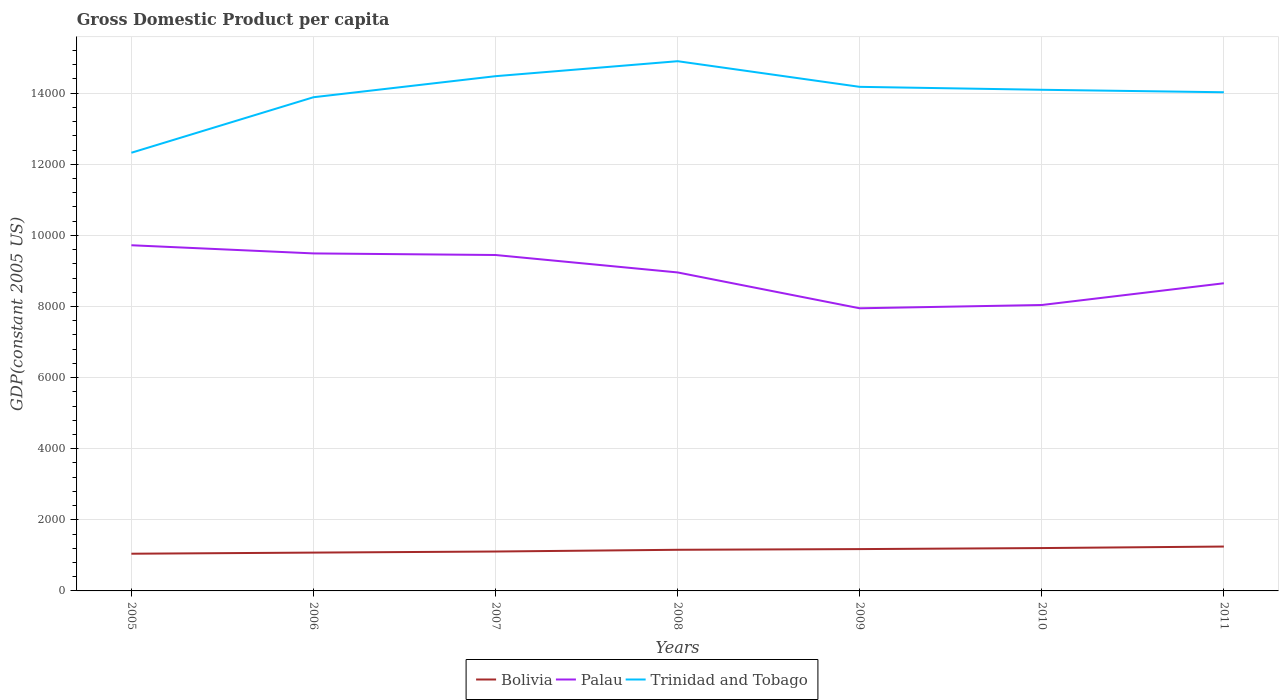How many different coloured lines are there?
Your response must be concise. 3. Does the line corresponding to Palau intersect with the line corresponding to Bolivia?
Your answer should be compact. No. Is the number of lines equal to the number of legend labels?
Your answer should be compact. Yes. Across all years, what is the maximum GDP per capita in Trinidad and Tobago?
Offer a very short reply. 1.23e+04. What is the total GDP per capita in Palau in the graph?
Offer a terse response. 490.37. What is the difference between the highest and the second highest GDP per capita in Bolivia?
Your response must be concise. 201.41. Are the values on the major ticks of Y-axis written in scientific E-notation?
Your response must be concise. No. Where does the legend appear in the graph?
Offer a very short reply. Bottom center. How are the legend labels stacked?
Provide a short and direct response. Horizontal. What is the title of the graph?
Give a very brief answer. Gross Domestic Product per capita. What is the label or title of the X-axis?
Ensure brevity in your answer.  Years. What is the label or title of the Y-axis?
Your response must be concise. GDP(constant 2005 US). What is the GDP(constant 2005 US) in Bolivia in 2005?
Ensure brevity in your answer.  1046.43. What is the GDP(constant 2005 US) in Palau in 2005?
Ensure brevity in your answer.  9721.5. What is the GDP(constant 2005 US) of Trinidad and Tobago in 2005?
Keep it short and to the point. 1.23e+04. What is the GDP(constant 2005 US) of Bolivia in 2006?
Offer a terse response. 1077.97. What is the GDP(constant 2005 US) in Palau in 2006?
Make the answer very short. 9491.85. What is the GDP(constant 2005 US) in Trinidad and Tobago in 2006?
Ensure brevity in your answer.  1.39e+04. What is the GDP(constant 2005 US) in Bolivia in 2007?
Provide a short and direct response. 1108.29. What is the GDP(constant 2005 US) of Palau in 2007?
Provide a succinct answer. 9447.16. What is the GDP(constant 2005 US) of Trinidad and Tobago in 2007?
Offer a very short reply. 1.45e+04. What is the GDP(constant 2005 US) in Bolivia in 2008?
Offer a very short reply. 1157.02. What is the GDP(constant 2005 US) of Palau in 2008?
Your answer should be compact. 8956.79. What is the GDP(constant 2005 US) of Trinidad and Tobago in 2008?
Ensure brevity in your answer.  1.49e+04. What is the GDP(constant 2005 US) in Bolivia in 2009?
Keep it short and to the point. 1176.39. What is the GDP(constant 2005 US) of Palau in 2009?
Your answer should be very brief. 7948.6. What is the GDP(constant 2005 US) of Trinidad and Tobago in 2009?
Keep it short and to the point. 1.42e+04. What is the GDP(constant 2005 US) of Bolivia in 2010?
Offer a very short reply. 1205.24. What is the GDP(constant 2005 US) of Palau in 2010?
Your response must be concise. 8041.01. What is the GDP(constant 2005 US) in Trinidad and Tobago in 2010?
Provide a succinct answer. 1.41e+04. What is the GDP(constant 2005 US) in Bolivia in 2011?
Offer a terse response. 1247.84. What is the GDP(constant 2005 US) in Palau in 2011?
Your answer should be very brief. 8652.35. What is the GDP(constant 2005 US) in Trinidad and Tobago in 2011?
Your response must be concise. 1.40e+04. Across all years, what is the maximum GDP(constant 2005 US) in Bolivia?
Provide a short and direct response. 1247.84. Across all years, what is the maximum GDP(constant 2005 US) of Palau?
Offer a terse response. 9721.5. Across all years, what is the maximum GDP(constant 2005 US) in Trinidad and Tobago?
Keep it short and to the point. 1.49e+04. Across all years, what is the minimum GDP(constant 2005 US) of Bolivia?
Ensure brevity in your answer.  1046.43. Across all years, what is the minimum GDP(constant 2005 US) of Palau?
Make the answer very short. 7948.6. Across all years, what is the minimum GDP(constant 2005 US) of Trinidad and Tobago?
Your answer should be very brief. 1.23e+04. What is the total GDP(constant 2005 US) of Bolivia in the graph?
Give a very brief answer. 8019.18. What is the total GDP(constant 2005 US) of Palau in the graph?
Ensure brevity in your answer.  6.23e+04. What is the total GDP(constant 2005 US) of Trinidad and Tobago in the graph?
Your answer should be compact. 9.79e+04. What is the difference between the GDP(constant 2005 US) in Bolivia in 2005 and that in 2006?
Make the answer very short. -31.54. What is the difference between the GDP(constant 2005 US) of Palau in 2005 and that in 2006?
Provide a short and direct response. 229.65. What is the difference between the GDP(constant 2005 US) in Trinidad and Tobago in 2005 and that in 2006?
Keep it short and to the point. -1561.05. What is the difference between the GDP(constant 2005 US) of Bolivia in 2005 and that in 2007?
Your answer should be very brief. -61.86. What is the difference between the GDP(constant 2005 US) in Palau in 2005 and that in 2007?
Your answer should be very brief. 274.34. What is the difference between the GDP(constant 2005 US) of Trinidad and Tobago in 2005 and that in 2007?
Keep it short and to the point. -2153.18. What is the difference between the GDP(constant 2005 US) of Bolivia in 2005 and that in 2008?
Keep it short and to the point. -110.59. What is the difference between the GDP(constant 2005 US) of Palau in 2005 and that in 2008?
Your answer should be very brief. 764.71. What is the difference between the GDP(constant 2005 US) of Trinidad and Tobago in 2005 and that in 2008?
Make the answer very short. -2574.42. What is the difference between the GDP(constant 2005 US) of Bolivia in 2005 and that in 2009?
Give a very brief answer. -129.96. What is the difference between the GDP(constant 2005 US) of Palau in 2005 and that in 2009?
Your answer should be very brief. 1772.9. What is the difference between the GDP(constant 2005 US) in Trinidad and Tobago in 2005 and that in 2009?
Keep it short and to the point. -1853.08. What is the difference between the GDP(constant 2005 US) in Bolivia in 2005 and that in 2010?
Provide a succinct answer. -158.82. What is the difference between the GDP(constant 2005 US) of Palau in 2005 and that in 2010?
Make the answer very short. 1680.49. What is the difference between the GDP(constant 2005 US) of Trinidad and Tobago in 2005 and that in 2010?
Ensure brevity in your answer.  -1770.83. What is the difference between the GDP(constant 2005 US) of Bolivia in 2005 and that in 2011?
Provide a succinct answer. -201.41. What is the difference between the GDP(constant 2005 US) of Palau in 2005 and that in 2011?
Provide a succinct answer. 1069.15. What is the difference between the GDP(constant 2005 US) of Trinidad and Tobago in 2005 and that in 2011?
Your answer should be compact. -1701.08. What is the difference between the GDP(constant 2005 US) in Bolivia in 2006 and that in 2007?
Provide a short and direct response. -30.32. What is the difference between the GDP(constant 2005 US) in Palau in 2006 and that in 2007?
Keep it short and to the point. 44.69. What is the difference between the GDP(constant 2005 US) of Trinidad and Tobago in 2006 and that in 2007?
Keep it short and to the point. -592.13. What is the difference between the GDP(constant 2005 US) in Bolivia in 2006 and that in 2008?
Provide a short and direct response. -79.05. What is the difference between the GDP(constant 2005 US) in Palau in 2006 and that in 2008?
Make the answer very short. 535.07. What is the difference between the GDP(constant 2005 US) in Trinidad and Tobago in 2006 and that in 2008?
Provide a short and direct response. -1013.37. What is the difference between the GDP(constant 2005 US) of Bolivia in 2006 and that in 2009?
Offer a very short reply. -98.42. What is the difference between the GDP(constant 2005 US) of Palau in 2006 and that in 2009?
Offer a terse response. 1543.26. What is the difference between the GDP(constant 2005 US) of Trinidad and Tobago in 2006 and that in 2009?
Your answer should be compact. -292.03. What is the difference between the GDP(constant 2005 US) in Bolivia in 2006 and that in 2010?
Give a very brief answer. -127.28. What is the difference between the GDP(constant 2005 US) in Palau in 2006 and that in 2010?
Give a very brief answer. 1450.84. What is the difference between the GDP(constant 2005 US) of Trinidad and Tobago in 2006 and that in 2010?
Make the answer very short. -209.78. What is the difference between the GDP(constant 2005 US) of Bolivia in 2006 and that in 2011?
Keep it short and to the point. -169.87. What is the difference between the GDP(constant 2005 US) of Palau in 2006 and that in 2011?
Your answer should be very brief. 839.5. What is the difference between the GDP(constant 2005 US) in Trinidad and Tobago in 2006 and that in 2011?
Provide a short and direct response. -140.03. What is the difference between the GDP(constant 2005 US) of Bolivia in 2007 and that in 2008?
Your answer should be very brief. -48.73. What is the difference between the GDP(constant 2005 US) of Palau in 2007 and that in 2008?
Offer a terse response. 490.37. What is the difference between the GDP(constant 2005 US) in Trinidad and Tobago in 2007 and that in 2008?
Provide a succinct answer. -421.24. What is the difference between the GDP(constant 2005 US) of Bolivia in 2007 and that in 2009?
Keep it short and to the point. -68.1. What is the difference between the GDP(constant 2005 US) in Palau in 2007 and that in 2009?
Ensure brevity in your answer.  1498.56. What is the difference between the GDP(constant 2005 US) of Trinidad and Tobago in 2007 and that in 2009?
Your response must be concise. 300.1. What is the difference between the GDP(constant 2005 US) in Bolivia in 2007 and that in 2010?
Provide a short and direct response. -96.95. What is the difference between the GDP(constant 2005 US) in Palau in 2007 and that in 2010?
Your response must be concise. 1406.15. What is the difference between the GDP(constant 2005 US) in Trinidad and Tobago in 2007 and that in 2010?
Your response must be concise. 382.35. What is the difference between the GDP(constant 2005 US) of Bolivia in 2007 and that in 2011?
Your response must be concise. -139.55. What is the difference between the GDP(constant 2005 US) of Palau in 2007 and that in 2011?
Offer a terse response. 794.81. What is the difference between the GDP(constant 2005 US) of Trinidad and Tobago in 2007 and that in 2011?
Give a very brief answer. 452.1. What is the difference between the GDP(constant 2005 US) in Bolivia in 2008 and that in 2009?
Make the answer very short. -19.37. What is the difference between the GDP(constant 2005 US) of Palau in 2008 and that in 2009?
Give a very brief answer. 1008.19. What is the difference between the GDP(constant 2005 US) in Trinidad and Tobago in 2008 and that in 2009?
Give a very brief answer. 721.35. What is the difference between the GDP(constant 2005 US) of Bolivia in 2008 and that in 2010?
Give a very brief answer. -48.23. What is the difference between the GDP(constant 2005 US) in Palau in 2008 and that in 2010?
Keep it short and to the point. 915.77. What is the difference between the GDP(constant 2005 US) in Trinidad and Tobago in 2008 and that in 2010?
Offer a very short reply. 803.6. What is the difference between the GDP(constant 2005 US) of Bolivia in 2008 and that in 2011?
Your response must be concise. -90.82. What is the difference between the GDP(constant 2005 US) of Palau in 2008 and that in 2011?
Offer a very short reply. 304.43. What is the difference between the GDP(constant 2005 US) of Trinidad and Tobago in 2008 and that in 2011?
Your answer should be compact. 873.34. What is the difference between the GDP(constant 2005 US) in Bolivia in 2009 and that in 2010?
Ensure brevity in your answer.  -28.85. What is the difference between the GDP(constant 2005 US) of Palau in 2009 and that in 2010?
Ensure brevity in your answer.  -92.42. What is the difference between the GDP(constant 2005 US) in Trinidad and Tobago in 2009 and that in 2010?
Ensure brevity in your answer.  82.25. What is the difference between the GDP(constant 2005 US) in Bolivia in 2009 and that in 2011?
Provide a short and direct response. -71.45. What is the difference between the GDP(constant 2005 US) in Palau in 2009 and that in 2011?
Ensure brevity in your answer.  -703.76. What is the difference between the GDP(constant 2005 US) in Trinidad and Tobago in 2009 and that in 2011?
Offer a very short reply. 152. What is the difference between the GDP(constant 2005 US) of Bolivia in 2010 and that in 2011?
Offer a very short reply. -42.59. What is the difference between the GDP(constant 2005 US) in Palau in 2010 and that in 2011?
Offer a terse response. -611.34. What is the difference between the GDP(constant 2005 US) of Trinidad and Tobago in 2010 and that in 2011?
Keep it short and to the point. 69.74. What is the difference between the GDP(constant 2005 US) in Bolivia in 2005 and the GDP(constant 2005 US) in Palau in 2006?
Your response must be concise. -8445.43. What is the difference between the GDP(constant 2005 US) in Bolivia in 2005 and the GDP(constant 2005 US) in Trinidad and Tobago in 2006?
Give a very brief answer. -1.28e+04. What is the difference between the GDP(constant 2005 US) in Palau in 2005 and the GDP(constant 2005 US) in Trinidad and Tobago in 2006?
Give a very brief answer. -4162.69. What is the difference between the GDP(constant 2005 US) in Bolivia in 2005 and the GDP(constant 2005 US) in Palau in 2007?
Provide a succinct answer. -8400.73. What is the difference between the GDP(constant 2005 US) in Bolivia in 2005 and the GDP(constant 2005 US) in Trinidad and Tobago in 2007?
Give a very brief answer. -1.34e+04. What is the difference between the GDP(constant 2005 US) of Palau in 2005 and the GDP(constant 2005 US) of Trinidad and Tobago in 2007?
Provide a short and direct response. -4754.82. What is the difference between the GDP(constant 2005 US) in Bolivia in 2005 and the GDP(constant 2005 US) in Palau in 2008?
Your answer should be compact. -7910.36. What is the difference between the GDP(constant 2005 US) of Bolivia in 2005 and the GDP(constant 2005 US) of Trinidad and Tobago in 2008?
Provide a short and direct response. -1.39e+04. What is the difference between the GDP(constant 2005 US) in Palau in 2005 and the GDP(constant 2005 US) in Trinidad and Tobago in 2008?
Offer a very short reply. -5176.06. What is the difference between the GDP(constant 2005 US) of Bolivia in 2005 and the GDP(constant 2005 US) of Palau in 2009?
Provide a short and direct response. -6902.17. What is the difference between the GDP(constant 2005 US) in Bolivia in 2005 and the GDP(constant 2005 US) in Trinidad and Tobago in 2009?
Your answer should be very brief. -1.31e+04. What is the difference between the GDP(constant 2005 US) in Palau in 2005 and the GDP(constant 2005 US) in Trinidad and Tobago in 2009?
Give a very brief answer. -4454.71. What is the difference between the GDP(constant 2005 US) in Bolivia in 2005 and the GDP(constant 2005 US) in Palau in 2010?
Your response must be concise. -6994.59. What is the difference between the GDP(constant 2005 US) of Bolivia in 2005 and the GDP(constant 2005 US) of Trinidad and Tobago in 2010?
Make the answer very short. -1.30e+04. What is the difference between the GDP(constant 2005 US) of Palau in 2005 and the GDP(constant 2005 US) of Trinidad and Tobago in 2010?
Offer a very short reply. -4372.46. What is the difference between the GDP(constant 2005 US) in Bolivia in 2005 and the GDP(constant 2005 US) in Palau in 2011?
Make the answer very short. -7605.93. What is the difference between the GDP(constant 2005 US) of Bolivia in 2005 and the GDP(constant 2005 US) of Trinidad and Tobago in 2011?
Provide a short and direct response. -1.30e+04. What is the difference between the GDP(constant 2005 US) in Palau in 2005 and the GDP(constant 2005 US) in Trinidad and Tobago in 2011?
Offer a very short reply. -4302.72. What is the difference between the GDP(constant 2005 US) of Bolivia in 2006 and the GDP(constant 2005 US) of Palau in 2007?
Ensure brevity in your answer.  -8369.19. What is the difference between the GDP(constant 2005 US) of Bolivia in 2006 and the GDP(constant 2005 US) of Trinidad and Tobago in 2007?
Offer a very short reply. -1.34e+04. What is the difference between the GDP(constant 2005 US) in Palau in 2006 and the GDP(constant 2005 US) in Trinidad and Tobago in 2007?
Your response must be concise. -4984.46. What is the difference between the GDP(constant 2005 US) in Bolivia in 2006 and the GDP(constant 2005 US) in Palau in 2008?
Offer a very short reply. -7878.82. What is the difference between the GDP(constant 2005 US) of Bolivia in 2006 and the GDP(constant 2005 US) of Trinidad and Tobago in 2008?
Your answer should be very brief. -1.38e+04. What is the difference between the GDP(constant 2005 US) in Palau in 2006 and the GDP(constant 2005 US) in Trinidad and Tobago in 2008?
Offer a terse response. -5405.71. What is the difference between the GDP(constant 2005 US) of Bolivia in 2006 and the GDP(constant 2005 US) of Palau in 2009?
Your response must be concise. -6870.63. What is the difference between the GDP(constant 2005 US) in Bolivia in 2006 and the GDP(constant 2005 US) in Trinidad and Tobago in 2009?
Ensure brevity in your answer.  -1.31e+04. What is the difference between the GDP(constant 2005 US) in Palau in 2006 and the GDP(constant 2005 US) in Trinidad and Tobago in 2009?
Your response must be concise. -4684.36. What is the difference between the GDP(constant 2005 US) in Bolivia in 2006 and the GDP(constant 2005 US) in Palau in 2010?
Your answer should be compact. -6963.05. What is the difference between the GDP(constant 2005 US) of Bolivia in 2006 and the GDP(constant 2005 US) of Trinidad and Tobago in 2010?
Keep it short and to the point. -1.30e+04. What is the difference between the GDP(constant 2005 US) in Palau in 2006 and the GDP(constant 2005 US) in Trinidad and Tobago in 2010?
Give a very brief answer. -4602.11. What is the difference between the GDP(constant 2005 US) of Bolivia in 2006 and the GDP(constant 2005 US) of Palau in 2011?
Your answer should be compact. -7574.39. What is the difference between the GDP(constant 2005 US) in Bolivia in 2006 and the GDP(constant 2005 US) in Trinidad and Tobago in 2011?
Your response must be concise. -1.29e+04. What is the difference between the GDP(constant 2005 US) of Palau in 2006 and the GDP(constant 2005 US) of Trinidad and Tobago in 2011?
Provide a succinct answer. -4532.37. What is the difference between the GDP(constant 2005 US) in Bolivia in 2007 and the GDP(constant 2005 US) in Palau in 2008?
Provide a short and direct response. -7848.5. What is the difference between the GDP(constant 2005 US) of Bolivia in 2007 and the GDP(constant 2005 US) of Trinidad and Tobago in 2008?
Your answer should be compact. -1.38e+04. What is the difference between the GDP(constant 2005 US) of Palau in 2007 and the GDP(constant 2005 US) of Trinidad and Tobago in 2008?
Provide a short and direct response. -5450.4. What is the difference between the GDP(constant 2005 US) in Bolivia in 2007 and the GDP(constant 2005 US) in Palau in 2009?
Provide a succinct answer. -6840.31. What is the difference between the GDP(constant 2005 US) of Bolivia in 2007 and the GDP(constant 2005 US) of Trinidad and Tobago in 2009?
Give a very brief answer. -1.31e+04. What is the difference between the GDP(constant 2005 US) in Palau in 2007 and the GDP(constant 2005 US) in Trinidad and Tobago in 2009?
Offer a very short reply. -4729.06. What is the difference between the GDP(constant 2005 US) in Bolivia in 2007 and the GDP(constant 2005 US) in Palau in 2010?
Offer a terse response. -6932.72. What is the difference between the GDP(constant 2005 US) of Bolivia in 2007 and the GDP(constant 2005 US) of Trinidad and Tobago in 2010?
Keep it short and to the point. -1.30e+04. What is the difference between the GDP(constant 2005 US) in Palau in 2007 and the GDP(constant 2005 US) in Trinidad and Tobago in 2010?
Provide a succinct answer. -4646.8. What is the difference between the GDP(constant 2005 US) of Bolivia in 2007 and the GDP(constant 2005 US) of Palau in 2011?
Provide a short and direct response. -7544.06. What is the difference between the GDP(constant 2005 US) in Bolivia in 2007 and the GDP(constant 2005 US) in Trinidad and Tobago in 2011?
Ensure brevity in your answer.  -1.29e+04. What is the difference between the GDP(constant 2005 US) of Palau in 2007 and the GDP(constant 2005 US) of Trinidad and Tobago in 2011?
Make the answer very short. -4577.06. What is the difference between the GDP(constant 2005 US) in Bolivia in 2008 and the GDP(constant 2005 US) in Palau in 2009?
Provide a succinct answer. -6791.58. What is the difference between the GDP(constant 2005 US) in Bolivia in 2008 and the GDP(constant 2005 US) in Trinidad and Tobago in 2009?
Your answer should be very brief. -1.30e+04. What is the difference between the GDP(constant 2005 US) in Palau in 2008 and the GDP(constant 2005 US) in Trinidad and Tobago in 2009?
Your response must be concise. -5219.43. What is the difference between the GDP(constant 2005 US) in Bolivia in 2008 and the GDP(constant 2005 US) in Palau in 2010?
Your answer should be compact. -6883.99. What is the difference between the GDP(constant 2005 US) in Bolivia in 2008 and the GDP(constant 2005 US) in Trinidad and Tobago in 2010?
Make the answer very short. -1.29e+04. What is the difference between the GDP(constant 2005 US) in Palau in 2008 and the GDP(constant 2005 US) in Trinidad and Tobago in 2010?
Your response must be concise. -5137.18. What is the difference between the GDP(constant 2005 US) in Bolivia in 2008 and the GDP(constant 2005 US) in Palau in 2011?
Your answer should be very brief. -7495.33. What is the difference between the GDP(constant 2005 US) in Bolivia in 2008 and the GDP(constant 2005 US) in Trinidad and Tobago in 2011?
Keep it short and to the point. -1.29e+04. What is the difference between the GDP(constant 2005 US) in Palau in 2008 and the GDP(constant 2005 US) in Trinidad and Tobago in 2011?
Keep it short and to the point. -5067.43. What is the difference between the GDP(constant 2005 US) in Bolivia in 2009 and the GDP(constant 2005 US) in Palau in 2010?
Give a very brief answer. -6864.62. What is the difference between the GDP(constant 2005 US) in Bolivia in 2009 and the GDP(constant 2005 US) in Trinidad and Tobago in 2010?
Your answer should be very brief. -1.29e+04. What is the difference between the GDP(constant 2005 US) of Palau in 2009 and the GDP(constant 2005 US) of Trinidad and Tobago in 2010?
Provide a succinct answer. -6145.37. What is the difference between the GDP(constant 2005 US) in Bolivia in 2009 and the GDP(constant 2005 US) in Palau in 2011?
Provide a succinct answer. -7475.96. What is the difference between the GDP(constant 2005 US) of Bolivia in 2009 and the GDP(constant 2005 US) of Trinidad and Tobago in 2011?
Offer a terse response. -1.28e+04. What is the difference between the GDP(constant 2005 US) of Palau in 2009 and the GDP(constant 2005 US) of Trinidad and Tobago in 2011?
Make the answer very short. -6075.62. What is the difference between the GDP(constant 2005 US) in Bolivia in 2010 and the GDP(constant 2005 US) in Palau in 2011?
Provide a succinct answer. -7447.11. What is the difference between the GDP(constant 2005 US) of Bolivia in 2010 and the GDP(constant 2005 US) of Trinidad and Tobago in 2011?
Provide a short and direct response. -1.28e+04. What is the difference between the GDP(constant 2005 US) in Palau in 2010 and the GDP(constant 2005 US) in Trinidad and Tobago in 2011?
Provide a short and direct response. -5983.21. What is the average GDP(constant 2005 US) of Bolivia per year?
Offer a very short reply. 1145.6. What is the average GDP(constant 2005 US) in Palau per year?
Ensure brevity in your answer.  8894.18. What is the average GDP(constant 2005 US) in Trinidad and Tobago per year?
Offer a very short reply. 1.40e+04. In the year 2005, what is the difference between the GDP(constant 2005 US) of Bolivia and GDP(constant 2005 US) of Palau?
Make the answer very short. -8675.07. In the year 2005, what is the difference between the GDP(constant 2005 US) in Bolivia and GDP(constant 2005 US) in Trinidad and Tobago?
Provide a succinct answer. -1.13e+04. In the year 2005, what is the difference between the GDP(constant 2005 US) of Palau and GDP(constant 2005 US) of Trinidad and Tobago?
Ensure brevity in your answer.  -2601.64. In the year 2006, what is the difference between the GDP(constant 2005 US) of Bolivia and GDP(constant 2005 US) of Palau?
Make the answer very short. -8413.89. In the year 2006, what is the difference between the GDP(constant 2005 US) in Bolivia and GDP(constant 2005 US) in Trinidad and Tobago?
Your answer should be compact. -1.28e+04. In the year 2006, what is the difference between the GDP(constant 2005 US) of Palau and GDP(constant 2005 US) of Trinidad and Tobago?
Offer a very short reply. -4392.33. In the year 2007, what is the difference between the GDP(constant 2005 US) in Bolivia and GDP(constant 2005 US) in Palau?
Keep it short and to the point. -8338.87. In the year 2007, what is the difference between the GDP(constant 2005 US) in Bolivia and GDP(constant 2005 US) in Trinidad and Tobago?
Your answer should be compact. -1.34e+04. In the year 2007, what is the difference between the GDP(constant 2005 US) in Palau and GDP(constant 2005 US) in Trinidad and Tobago?
Your response must be concise. -5029.16. In the year 2008, what is the difference between the GDP(constant 2005 US) of Bolivia and GDP(constant 2005 US) of Palau?
Your response must be concise. -7799.77. In the year 2008, what is the difference between the GDP(constant 2005 US) in Bolivia and GDP(constant 2005 US) in Trinidad and Tobago?
Your response must be concise. -1.37e+04. In the year 2008, what is the difference between the GDP(constant 2005 US) of Palau and GDP(constant 2005 US) of Trinidad and Tobago?
Your response must be concise. -5940.77. In the year 2009, what is the difference between the GDP(constant 2005 US) in Bolivia and GDP(constant 2005 US) in Palau?
Offer a very short reply. -6772.21. In the year 2009, what is the difference between the GDP(constant 2005 US) of Bolivia and GDP(constant 2005 US) of Trinidad and Tobago?
Give a very brief answer. -1.30e+04. In the year 2009, what is the difference between the GDP(constant 2005 US) in Palau and GDP(constant 2005 US) in Trinidad and Tobago?
Offer a very short reply. -6227.62. In the year 2010, what is the difference between the GDP(constant 2005 US) in Bolivia and GDP(constant 2005 US) in Palau?
Ensure brevity in your answer.  -6835.77. In the year 2010, what is the difference between the GDP(constant 2005 US) in Bolivia and GDP(constant 2005 US) in Trinidad and Tobago?
Keep it short and to the point. -1.29e+04. In the year 2010, what is the difference between the GDP(constant 2005 US) of Palau and GDP(constant 2005 US) of Trinidad and Tobago?
Offer a terse response. -6052.95. In the year 2011, what is the difference between the GDP(constant 2005 US) in Bolivia and GDP(constant 2005 US) in Palau?
Provide a short and direct response. -7404.52. In the year 2011, what is the difference between the GDP(constant 2005 US) of Bolivia and GDP(constant 2005 US) of Trinidad and Tobago?
Provide a succinct answer. -1.28e+04. In the year 2011, what is the difference between the GDP(constant 2005 US) of Palau and GDP(constant 2005 US) of Trinidad and Tobago?
Offer a very short reply. -5371.87. What is the ratio of the GDP(constant 2005 US) of Bolivia in 2005 to that in 2006?
Offer a terse response. 0.97. What is the ratio of the GDP(constant 2005 US) in Palau in 2005 to that in 2006?
Give a very brief answer. 1.02. What is the ratio of the GDP(constant 2005 US) in Trinidad and Tobago in 2005 to that in 2006?
Offer a terse response. 0.89. What is the ratio of the GDP(constant 2005 US) of Bolivia in 2005 to that in 2007?
Make the answer very short. 0.94. What is the ratio of the GDP(constant 2005 US) in Trinidad and Tobago in 2005 to that in 2007?
Offer a terse response. 0.85. What is the ratio of the GDP(constant 2005 US) of Bolivia in 2005 to that in 2008?
Your answer should be compact. 0.9. What is the ratio of the GDP(constant 2005 US) in Palau in 2005 to that in 2008?
Give a very brief answer. 1.09. What is the ratio of the GDP(constant 2005 US) in Trinidad and Tobago in 2005 to that in 2008?
Ensure brevity in your answer.  0.83. What is the ratio of the GDP(constant 2005 US) of Bolivia in 2005 to that in 2009?
Offer a very short reply. 0.89. What is the ratio of the GDP(constant 2005 US) of Palau in 2005 to that in 2009?
Your answer should be very brief. 1.22. What is the ratio of the GDP(constant 2005 US) of Trinidad and Tobago in 2005 to that in 2009?
Provide a succinct answer. 0.87. What is the ratio of the GDP(constant 2005 US) in Bolivia in 2005 to that in 2010?
Your answer should be compact. 0.87. What is the ratio of the GDP(constant 2005 US) of Palau in 2005 to that in 2010?
Your answer should be very brief. 1.21. What is the ratio of the GDP(constant 2005 US) of Trinidad and Tobago in 2005 to that in 2010?
Make the answer very short. 0.87. What is the ratio of the GDP(constant 2005 US) in Bolivia in 2005 to that in 2011?
Your answer should be compact. 0.84. What is the ratio of the GDP(constant 2005 US) of Palau in 2005 to that in 2011?
Give a very brief answer. 1.12. What is the ratio of the GDP(constant 2005 US) in Trinidad and Tobago in 2005 to that in 2011?
Your answer should be compact. 0.88. What is the ratio of the GDP(constant 2005 US) of Bolivia in 2006 to that in 2007?
Provide a succinct answer. 0.97. What is the ratio of the GDP(constant 2005 US) in Palau in 2006 to that in 2007?
Give a very brief answer. 1. What is the ratio of the GDP(constant 2005 US) of Trinidad and Tobago in 2006 to that in 2007?
Provide a short and direct response. 0.96. What is the ratio of the GDP(constant 2005 US) in Bolivia in 2006 to that in 2008?
Provide a succinct answer. 0.93. What is the ratio of the GDP(constant 2005 US) of Palau in 2006 to that in 2008?
Give a very brief answer. 1.06. What is the ratio of the GDP(constant 2005 US) in Trinidad and Tobago in 2006 to that in 2008?
Ensure brevity in your answer.  0.93. What is the ratio of the GDP(constant 2005 US) of Bolivia in 2006 to that in 2009?
Provide a succinct answer. 0.92. What is the ratio of the GDP(constant 2005 US) in Palau in 2006 to that in 2009?
Your answer should be compact. 1.19. What is the ratio of the GDP(constant 2005 US) in Trinidad and Tobago in 2006 to that in 2009?
Provide a short and direct response. 0.98. What is the ratio of the GDP(constant 2005 US) of Bolivia in 2006 to that in 2010?
Keep it short and to the point. 0.89. What is the ratio of the GDP(constant 2005 US) of Palau in 2006 to that in 2010?
Give a very brief answer. 1.18. What is the ratio of the GDP(constant 2005 US) in Trinidad and Tobago in 2006 to that in 2010?
Provide a short and direct response. 0.99. What is the ratio of the GDP(constant 2005 US) of Bolivia in 2006 to that in 2011?
Make the answer very short. 0.86. What is the ratio of the GDP(constant 2005 US) in Palau in 2006 to that in 2011?
Offer a very short reply. 1.1. What is the ratio of the GDP(constant 2005 US) in Bolivia in 2007 to that in 2008?
Make the answer very short. 0.96. What is the ratio of the GDP(constant 2005 US) in Palau in 2007 to that in 2008?
Provide a short and direct response. 1.05. What is the ratio of the GDP(constant 2005 US) in Trinidad and Tobago in 2007 to that in 2008?
Provide a short and direct response. 0.97. What is the ratio of the GDP(constant 2005 US) of Bolivia in 2007 to that in 2009?
Provide a short and direct response. 0.94. What is the ratio of the GDP(constant 2005 US) in Palau in 2007 to that in 2009?
Offer a terse response. 1.19. What is the ratio of the GDP(constant 2005 US) of Trinidad and Tobago in 2007 to that in 2009?
Ensure brevity in your answer.  1.02. What is the ratio of the GDP(constant 2005 US) in Bolivia in 2007 to that in 2010?
Ensure brevity in your answer.  0.92. What is the ratio of the GDP(constant 2005 US) in Palau in 2007 to that in 2010?
Offer a very short reply. 1.17. What is the ratio of the GDP(constant 2005 US) in Trinidad and Tobago in 2007 to that in 2010?
Offer a very short reply. 1.03. What is the ratio of the GDP(constant 2005 US) in Bolivia in 2007 to that in 2011?
Offer a terse response. 0.89. What is the ratio of the GDP(constant 2005 US) of Palau in 2007 to that in 2011?
Offer a terse response. 1.09. What is the ratio of the GDP(constant 2005 US) in Trinidad and Tobago in 2007 to that in 2011?
Offer a terse response. 1.03. What is the ratio of the GDP(constant 2005 US) in Bolivia in 2008 to that in 2009?
Your answer should be compact. 0.98. What is the ratio of the GDP(constant 2005 US) in Palau in 2008 to that in 2009?
Give a very brief answer. 1.13. What is the ratio of the GDP(constant 2005 US) of Trinidad and Tobago in 2008 to that in 2009?
Provide a succinct answer. 1.05. What is the ratio of the GDP(constant 2005 US) of Palau in 2008 to that in 2010?
Ensure brevity in your answer.  1.11. What is the ratio of the GDP(constant 2005 US) of Trinidad and Tobago in 2008 to that in 2010?
Your answer should be very brief. 1.06. What is the ratio of the GDP(constant 2005 US) in Bolivia in 2008 to that in 2011?
Make the answer very short. 0.93. What is the ratio of the GDP(constant 2005 US) of Palau in 2008 to that in 2011?
Ensure brevity in your answer.  1.04. What is the ratio of the GDP(constant 2005 US) of Trinidad and Tobago in 2008 to that in 2011?
Offer a very short reply. 1.06. What is the ratio of the GDP(constant 2005 US) in Bolivia in 2009 to that in 2010?
Ensure brevity in your answer.  0.98. What is the ratio of the GDP(constant 2005 US) in Bolivia in 2009 to that in 2011?
Keep it short and to the point. 0.94. What is the ratio of the GDP(constant 2005 US) in Palau in 2009 to that in 2011?
Offer a terse response. 0.92. What is the ratio of the GDP(constant 2005 US) of Trinidad and Tobago in 2009 to that in 2011?
Your answer should be compact. 1.01. What is the ratio of the GDP(constant 2005 US) of Bolivia in 2010 to that in 2011?
Provide a short and direct response. 0.97. What is the ratio of the GDP(constant 2005 US) of Palau in 2010 to that in 2011?
Your response must be concise. 0.93. What is the ratio of the GDP(constant 2005 US) of Trinidad and Tobago in 2010 to that in 2011?
Ensure brevity in your answer.  1. What is the difference between the highest and the second highest GDP(constant 2005 US) in Bolivia?
Provide a succinct answer. 42.59. What is the difference between the highest and the second highest GDP(constant 2005 US) in Palau?
Ensure brevity in your answer.  229.65. What is the difference between the highest and the second highest GDP(constant 2005 US) in Trinidad and Tobago?
Offer a terse response. 421.24. What is the difference between the highest and the lowest GDP(constant 2005 US) of Bolivia?
Provide a short and direct response. 201.41. What is the difference between the highest and the lowest GDP(constant 2005 US) of Palau?
Offer a very short reply. 1772.9. What is the difference between the highest and the lowest GDP(constant 2005 US) in Trinidad and Tobago?
Offer a terse response. 2574.42. 